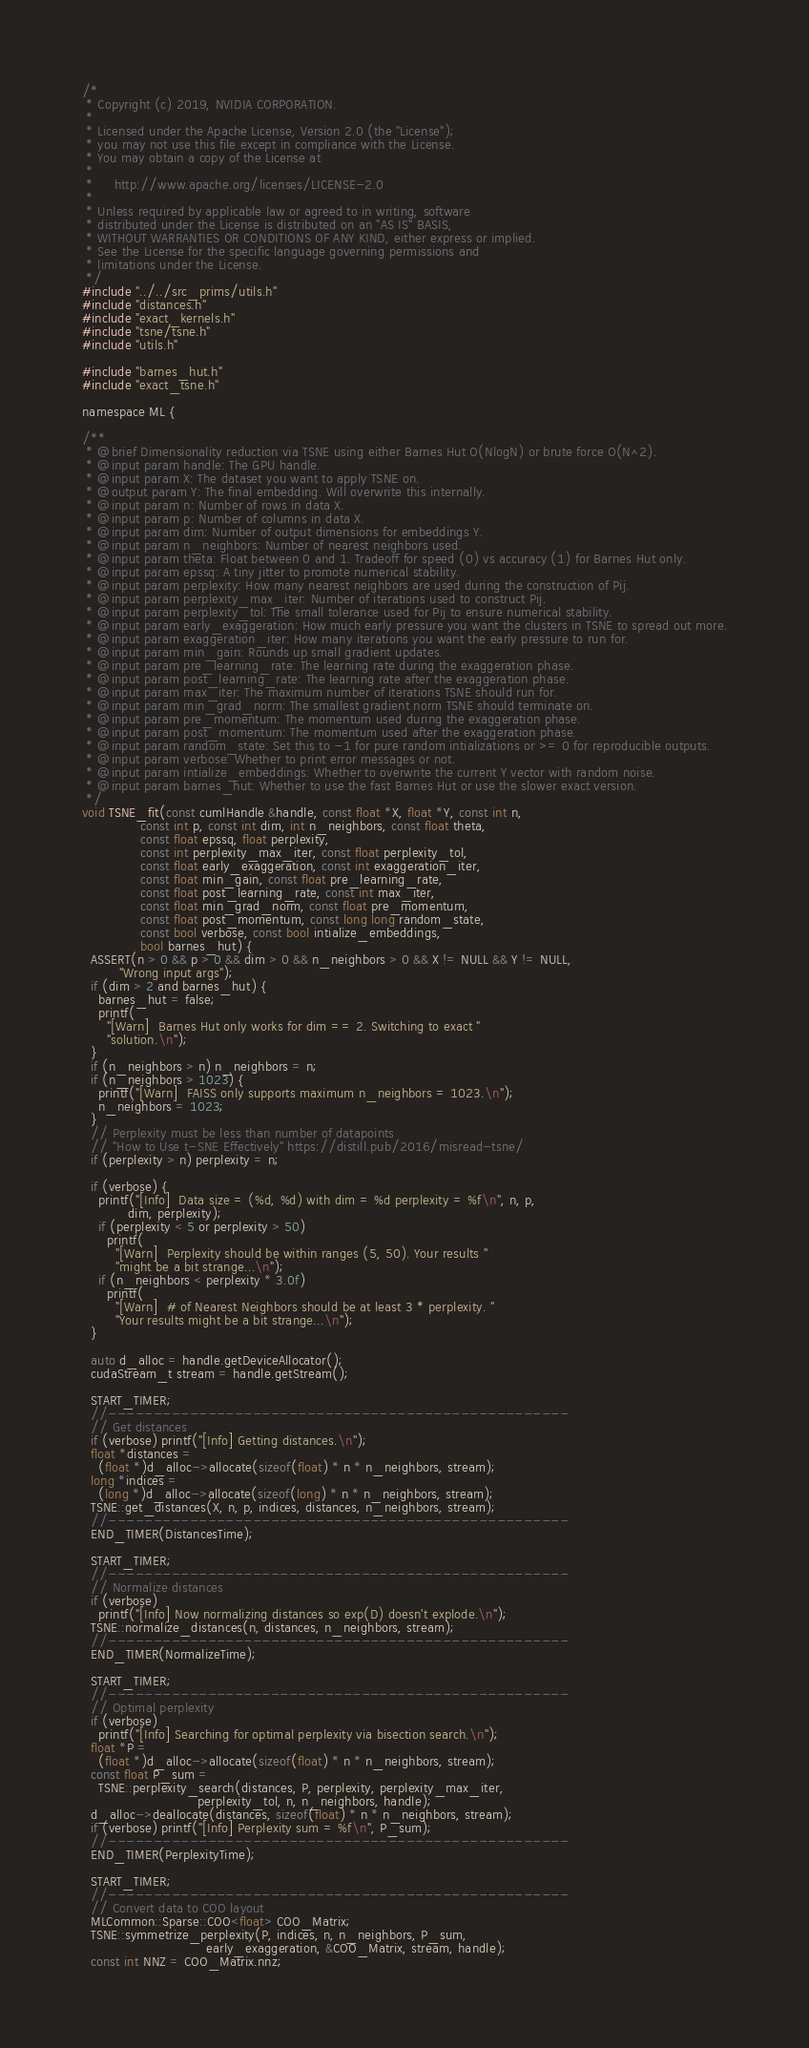<code> <loc_0><loc_0><loc_500><loc_500><_Cuda_>/*
 * Copyright (c) 2019, NVIDIA CORPORATION.
 *
 * Licensed under the Apache License, Version 2.0 (the "License");
 * you may not use this file except in compliance with the License.
 * You may obtain a copy of the License at
 *
 *     http://www.apache.org/licenses/LICENSE-2.0
 *
 * Unless required by applicable law or agreed to in writing, software
 * distributed under the License is distributed on an "AS IS" BASIS,
 * WITHOUT WARRANTIES OR CONDITIONS OF ANY KIND, either express or implied.
 * See the License for the specific language governing permissions and
 * limitations under the License.
 */
#include "../../src_prims/utils.h"
#include "distances.h"
#include "exact_kernels.h"
#include "tsne/tsne.h"
#include "utils.h"

#include "barnes_hut.h"
#include "exact_tsne.h"

namespace ML {

/**
 * @brief Dimensionality reduction via TSNE using either Barnes Hut O(NlogN) or brute force O(N^2).
 * @input param handle: The GPU handle.
 * @input param X: The dataset you want to apply TSNE on.
 * @output param Y: The final embedding. Will overwrite this internally.
 * @input param n: Number of rows in data X.
 * @input param p: Number of columns in data X.
 * @input param dim: Number of output dimensions for embeddings Y.
 * @input param n_neighbors: Number of nearest neighbors used.
 * @input param theta: Float between 0 and 1. Tradeoff for speed (0) vs accuracy (1) for Barnes Hut only.
 * @input param epssq: A tiny jitter to promote numerical stability.
 * @input param perplexity: How many nearest neighbors are used during the construction of Pij.
 * @input param perplexity_max_iter: Number of iterations used to construct Pij.
 * @input param perplexity_tol: The small tolerance used for Pij to ensure numerical stability.
 * @input param early_exaggeration: How much early pressure you want the clusters in TSNE to spread out more.
 * @input param exaggeration_iter: How many iterations you want the early pressure to run for.
 * @input param min_gain: Rounds up small gradient updates.
 * @input param pre_learning_rate: The learning rate during the exaggeration phase.
 * @input param post_learning_rate: The learning rate after the exaggeration phase.
 * @input param max_iter: The maximum number of iterations TSNE should run for.
 * @input param min_grad_norm: The smallest gradient norm TSNE should terminate on.
 * @input param pre_momentum: The momentum used during the exaggeration phase.
 * @input param post_momentum: The momentum used after the exaggeration phase.
 * @input param random_state: Set this to -1 for pure random intializations or >= 0 for reproducible outputs.
 * @input param verbose: Whether to print error messages or not.
 * @input param intialize_embeddings: Whether to overwrite the current Y vector with random noise.
 * @input param barnes_hut: Whether to use the fast Barnes Hut or use the slower exact version.
 */
void TSNE_fit(const cumlHandle &handle, const float *X, float *Y, const int n,
              const int p, const int dim, int n_neighbors, const float theta,
              const float epssq, float perplexity,
              const int perplexity_max_iter, const float perplexity_tol,
              const float early_exaggeration, const int exaggeration_iter,
              const float min_gain, const float pre_learning_rate,
              const float post_learning_rate, const int max_iter,
              const float min_grad_norm, const float pre_momentum,
              const float post_momentum, const long long random_state,
              const bool verbose, const bool intialize_embeddings,
              bool barnes_hut) {
  ASSERT(n > 0 && p > 0 && dim > 0 && n_neighbors > 0 && X != NULL && Y != NULL,
         "Wrong input args");
  if (dim > 2 and barnes_hut) {
    barnes_hut = false;
    printf(
      "[Warn]  Barnes Hut only works for dim == 2. Switching to exact "
      "solution.\n");
  }
  if (n_neighbors > n) n_neighbors = n;
  if (n_neighbors > 1023) {
    printf("[Warn]  FAISS only supports maximum n_neighbors = 1023.\n");
    n_neighbors = 1023;
  }
  // Perplexity must be less than number of datapoints
  // "How to Use t-SNE Effectively" https://distill.pub/2016/misread-tsne/
  if (perplexity > n) perplexity = n;

  if (verbose) {
    printf("[Info]  Data size = (%d, %d) with dim = %d perplexity = %f\n", n, p,
           dim, perplexity);
    if (perplexity < 5 or perplexity > 50)
      printf(
        "[Warn]  Perplexity should be within ranges (5, 50). Your results "
        "might be a bit strange...\n");
    if (n_neighbors < perplexity * 3.0f)
      printf(
        "[Warn]  # of Nearest Neighbors should be at least 3 * perplexity. "
        "Your results might be a bit strange...\n");
  }

  auto d_alloc = handle.getDeviceAllocator();
  cudaStream_t stream = handle.getStream();

  START_TIMER;
  //---------------------------------------------------
  // Get distances
  if (verbose) printf("[Info] Getting distances.\n");
  float *distances =
    (float *)d_alloc->allocate(sizeof(float) * n * n_neighbors, stream);
  long *indices =
    (long *)d_alloc->allocate(sizeof(long) * n * n_neighbors, stream);
  TSNE::get_distances(X, n, p, indices, distances, n_neighbors, stream);
  //---------------------------------------------------
  END_TIMER(DistancesTime);

  START_TIMER;
  //---------------------------------------------------
  // Normalize distances
  if (verbose)
    printf("[Info] Now normalizing distances so exp(D) doesn't explode.\n");
  TSNE::normalize_distances(n, distances, n_neighbors, stream);
  //---------------------------------------------------
  END_TIMER(NormalizeTime);

  START_TIMER;
  //---------------------------------------------------
  // Optimal perplexity
  if (verbose)
    printf("[Info] Searching for optimal perplexity via bisection search.\n");
  float *P =
    (float *)d_alloc->allocate(sizeof(float) * n * n_neighbors, stream);
  const float P_sum =
    TSNE::perplexity_search(distances, P, perplexity, perplexity_max_iter,
                            perplexity_tol, n, n_neighbors, handle);
  d_alloc->deallocate(distances, sizeof(float) * n * n_neighbors, stream);
  if (verbose) printf("[Info] Perplexity sum = %f\n", P_sum);
  //---------------------------------------------------
  END_TIMER(PerplexityTime);

  START_TIMER;
  //---------------------------------------------------
  // Convert data to COO layout
  MLCommon::Sparse::COO<float> COO_Matrix;
  TSNE::symmetrize_perplexity(P, indices, n, n_neighbors, P_sum,
                              early_exaggeration, &COO_Matrix, stream, handle);
  const int NNZ = COO_Matrix.nnz;</code> 